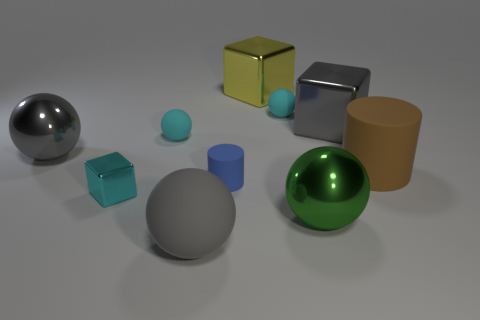Are there any small metal objects of the same shape as the big yellow metal thing?
Your answer should be very brief. Yes. Do the gray sphere that is in front of the cyan shiny cube and the gray metal sphere have the same size?
Your answer should be compact. Yes. There is a thing that is both on the right side of the big green sphere and on the left side of the big cylinder; how big is it?
Your response must be concise. Large. What number of other objects are the same material as the large yellow object?
Offer a very short reply. 4. What is the size of the gray metallic object that is to the right of the gray shiny ball?
Keep it short and to the point. Large. Is the tiny cylinder the same color as the small shiny thing?
Your response must be concise. No. What number of small things are yellow metallic objects or gray matte balls?
Offer a terse response. 0. Is there anything else that is the same color as the tiny shiny object?
Provide a short and direct response. Yes. Are there any blue things behind the small blue matte thing?
Provide a succinct answer. No. There is a gray thing that is behind the big shiny ball left of the cyan metallic thing; what is its size?
Your answer should be very brief. Large. 